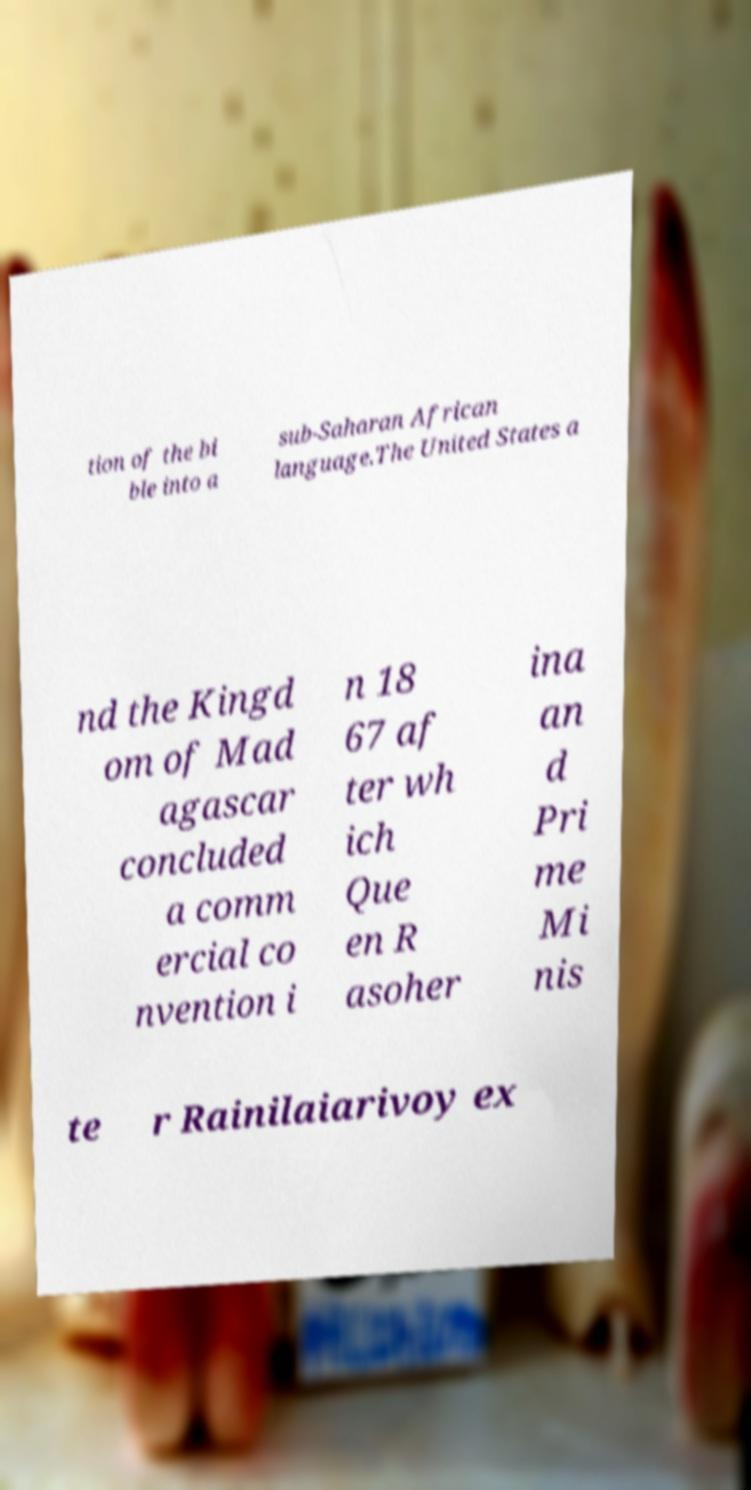Please read and relay the text visible in this image. What does it say? tion of the bi ble into a sub-Saharan African language.The United States a nd the Kingd om of Mad agascar concluded a comm ercial co nvention i n 18 67 af ter wh ich Que en R asoher ina an d Pri me Mi nis te r Rainilaiarivoy ex 